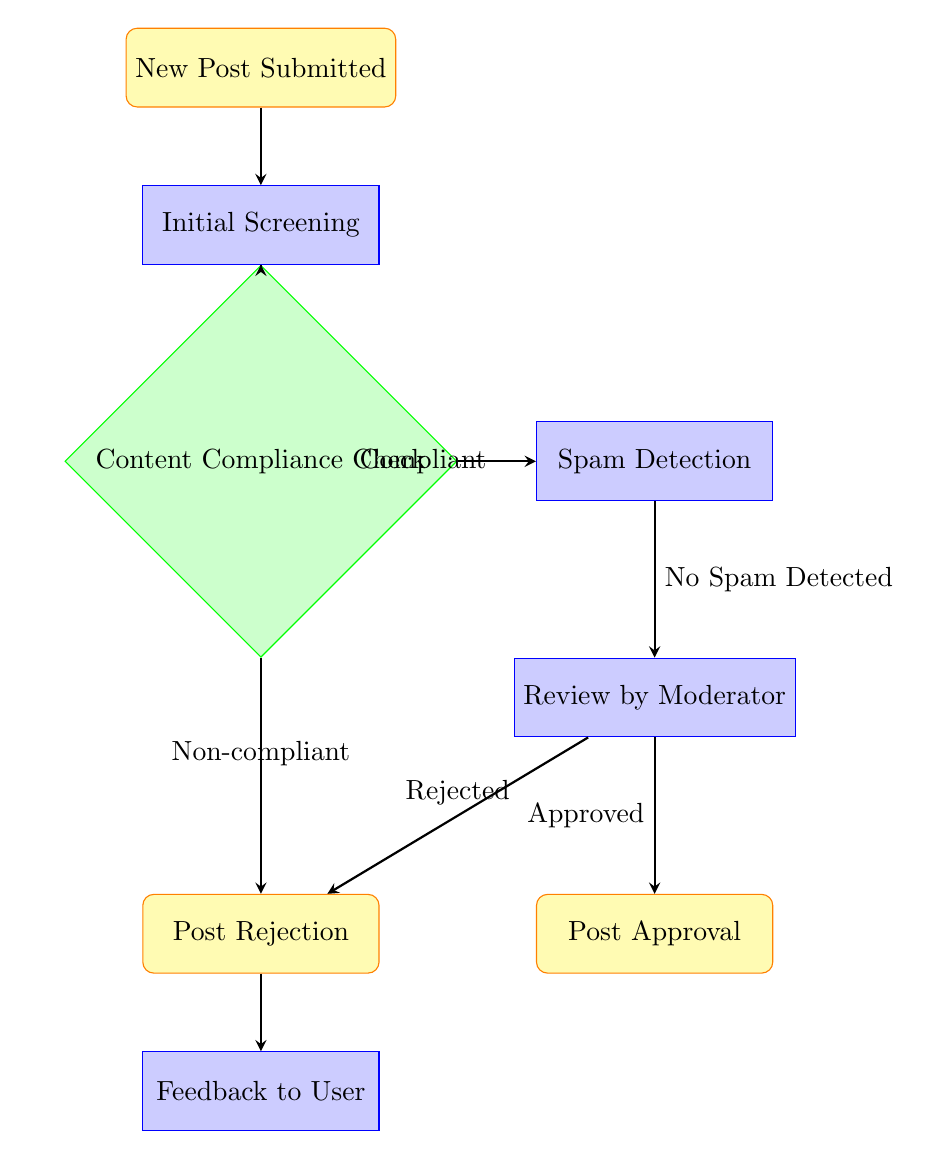What is the first step in the moderation process? The first step, as indicated by the flow chart, is "New Post Submitted." This is where the process begins before further screening and checks are conducted.
Answer: New Post Submitted How many nodes are there in the diagram? By counting all entries in the nodes section of the diagram, we find there are 8 distinct nodes representing different stages of the process.
Answer: 8 What happens if a post is found to be non-compliant? According to the flow chart, if a post is deemed non-compliant during the initial screening, it directly leads to the "Post Rejection" step, skipping further checks.
Answer: Post Rejection What checks are done after the initial screening? After the initial screening, the next step is the "Content Compliance Check," followed by potential spam detection if the content is compliant. This shows sequential stages in assessing the quality of the post.
Answer: Content Compliance Check What is the outcome following a "Review by Moderator"? The review can result in either "Post Approval" if the moderator approves the content, or "Post Rejection" if it does not meet the necessary criteria. This indicates the binary nature of the review step, leading to two possible outcomes.
Answer: Post Approval or Post Rejection What type of feedback is provided after post rejection? The flow chart specifies that "Feedback to User" is given after a post rejection, ensuring that users receive input on why their post was not approved. This is a crucial component of maintaining respectful and constructive discussions in the forum.
Answer: Feedback to User What node follows "Spam Detection"? The node that follows "Spam Detection" is "Review by Moderator." This shows that only posts without spam progress to moderation for further evaluation.
Answer: Review by Moderator What is the label of the arrow that leads from the "Content Compliance Check" to "Spam Detection"? The flow chart labels this arrow as "Compliant," indicating that only compliant posts proceed to spam detection, which is a critical part of the content evaluation process.
Answer: Compliant What happens to a post if spam is detected? If spam is detected during the spam detection step, it does not lead to a further decision in this diagram, as it signifies that the content has failed the moderation process and is rejected before reaching any approval stage.
Answer: Not explicitly stated (inferred as rejected) 